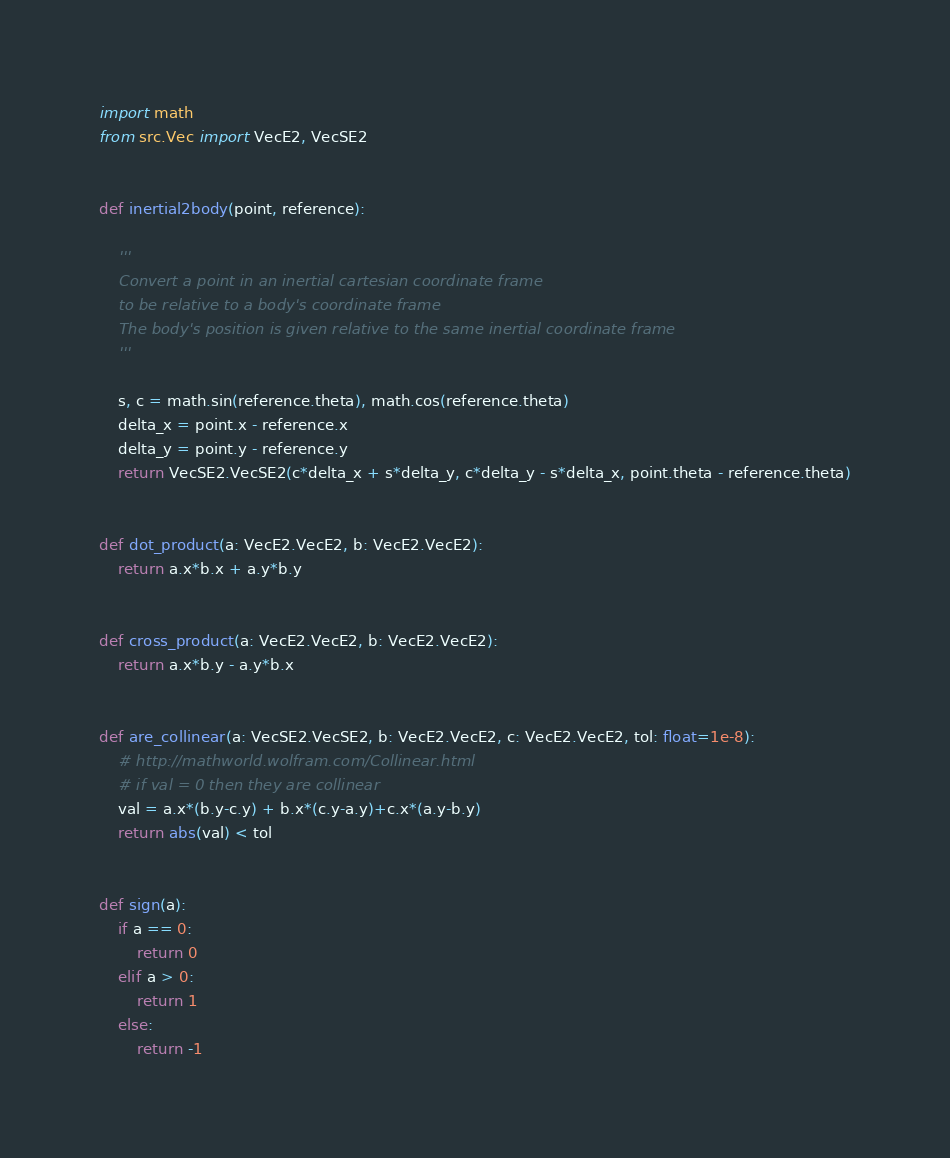<code> <loc_0><loc_0><loc_500><loc_500><_Python_>import math
from src.Vec import VecE2, VecSE2


def inertial2body(point, reference):

    '''
    Convert a point in an inertial cartesian coordinate frame
    to be relative to a body's coordinate frame
    The body's position is given relative to the same inertial coordinate frame
    '''

    s, c = math.sin(reference.theta), math.cos(reference.theta)
    delta_x = point.x - reference.x
    delta_y = point.y - reference.y
    return VecSE2.VecSE2(c*delta_x + s*delta_y, c*delta_y - s*delta_x, point.theta - reference.theta)


def dot_product(a: VecE2.VecE2, b: VecE2.VecE2):
    return a.x*b.x + a.y*b.y


def cross_product(a: VecE2.VecE2, b: VecE2.VecE2):
    return a.x*b.y - a.y*b.x


def are_collinear(a: VecSE2.VecSE2, b: VecE2.VecE2, c: VecE2.VecE2, tol: float=1e-8):
    # http://mathworld.wolfram.com/Collinear.html
    # if val = 0 then they are collinear
    val = a.x*(b.y-c.y) + b.x*(c.y-a.y)+c.x*(a.y-b.y)
    return abs(val) < tol


def sign(a):
    if a == 0:
        return 0
    elif a > 0:
        return 1
    else:
        return -1

</code> 